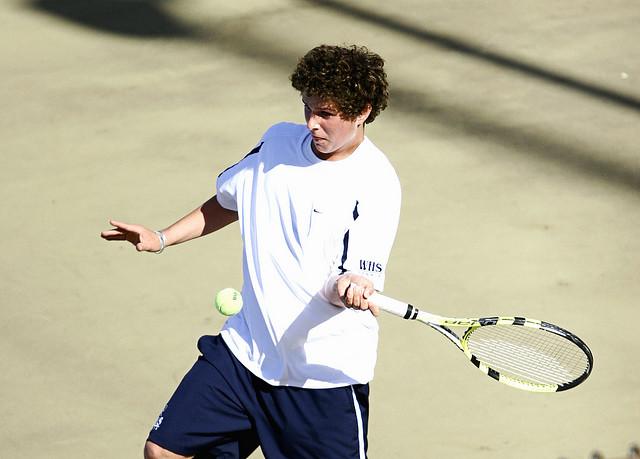What is the boy hitting?
Answer briefly. Tennis ball. What color shorts is he wearing?
Answer briefly. Blue. What sport is being played?
Answer briefly. Tennis. 